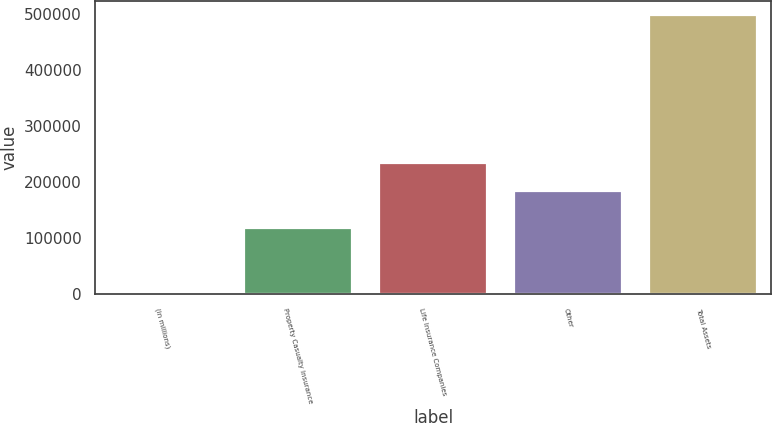Convert chart. <chart><loc_0><loc_0><loc_500><loc_500><bar_chart><fcel>(in millions)<fcel>Property Casualty Insurance<fcel>Life Insurance Companies<fcel>Other<fcel>Total Assets<nl><fcel>2016<fcel>118268<fcel>234329<fcel>184704<fcel>498264<nl></chart> 